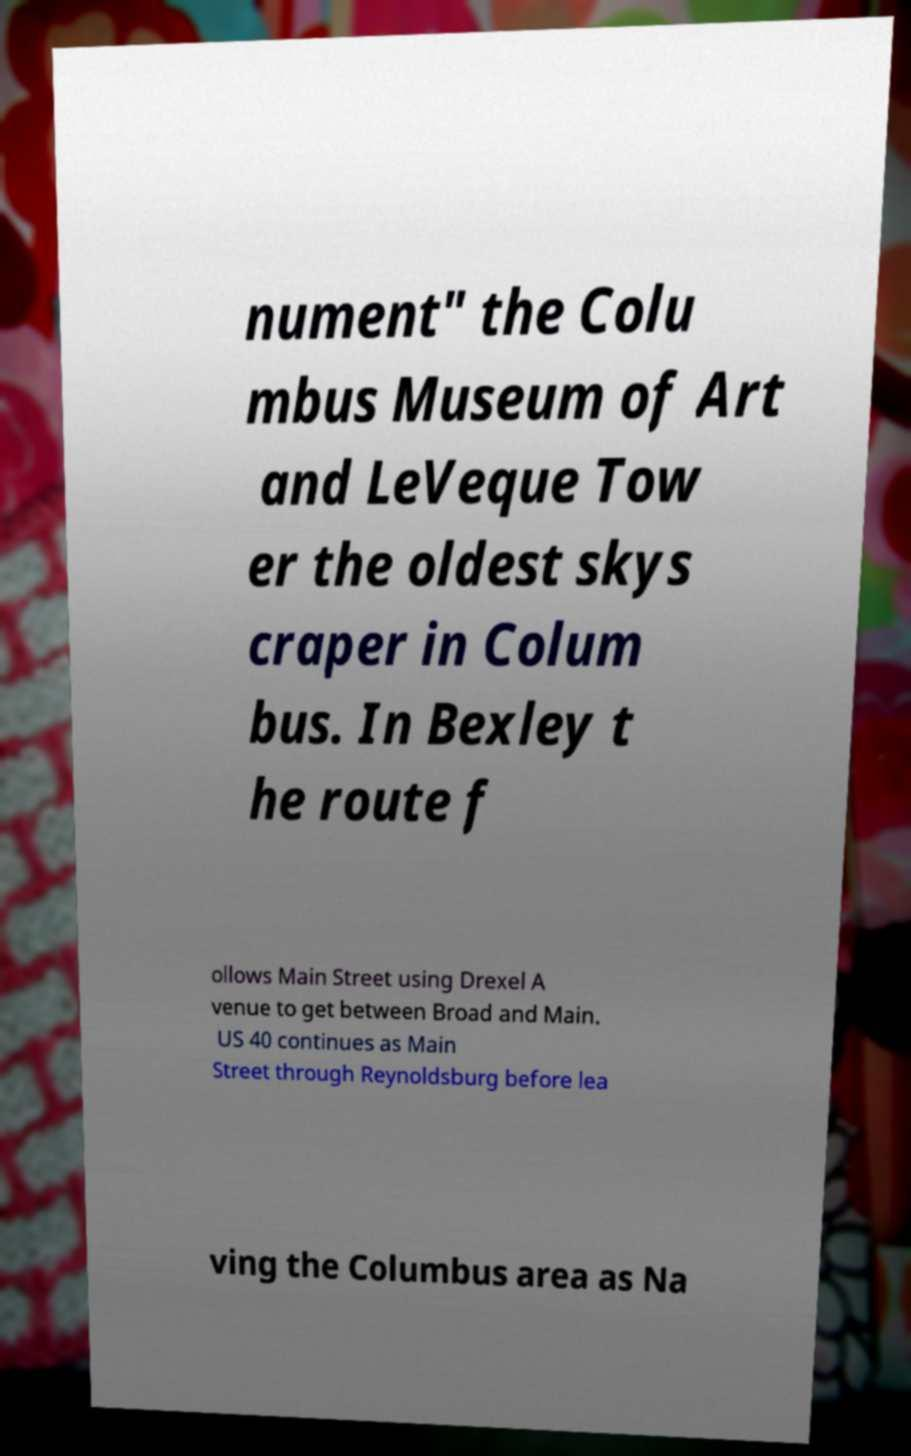Could you extract and type out the text from this image? nument" the Colu mbus Museum of Art and LeVeque Tow er the oldest skys craper in Colum bus. In Bexley t he route f ollows Main Street using Drexel A venue to get between Broad and Main. US 40 continues as Main Street through Reynoldsburg before lea ving the Columbus area as Na 